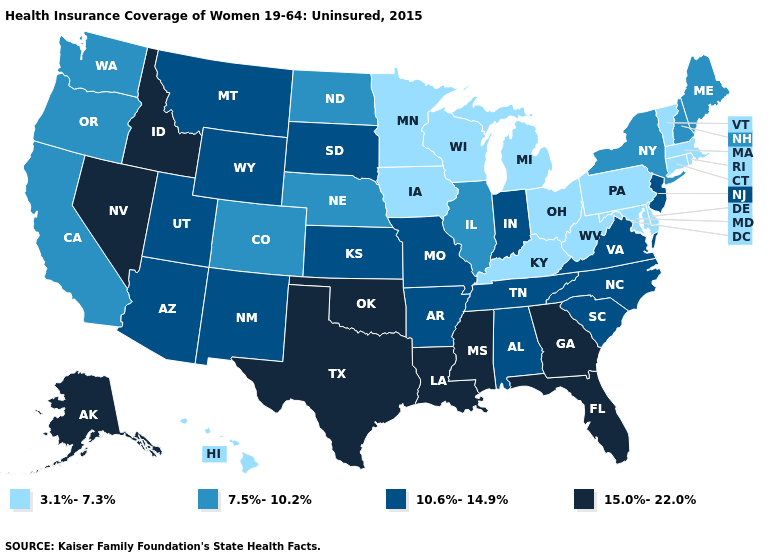Is the legend a continuous bar?
Short answer required. No. Which states hav the highest value in the Northeast?
Write a very short answer. New Jersey. What is the highest value in states that border Utah?
Short answer required. 15.0%-22.0%. What is the value of West Virginia?
Short answer required. 3.1%-7.3%. Does South Dakota have the highest value in the MidWest?
Quick response, please. Yes. Does South Carolina have a higher value than Arizona?
Concise answer only. No. Among the states that border Arizona , which have the lowest value?
Short answer required. California, Colorado. What is the value of Arkansas?
Quick response, please. 10.6%-14.9%. Does Tennessee have the highest value in the USA?
Give a very brief answer. No. Does Maine have a lower value than Kentucky?
Write a very short answer. No. What is the value of New Hampshire?
Write a very short answer. 7.5%-10.2%. Name the states that have a value in the range 3.1%-7.3%?
Answer briefly. Connecticut, Delaware, Hawaii, Iowa, Kentucky, Maryland, Massachusetts, Michigan, Minnesota, Ohio, Pennsylvania, Rhode Island, Vermont, West Virginia, Wisconsin. Does the first symbol in the legend represent the smallest category?
Be succinct. Yes. What is the highest value in the USA?
Give a very brief answer. 15.0%-22.0%. Among the states that border Wyoming , which have the highest value?
Concise answer only. Idaho. 